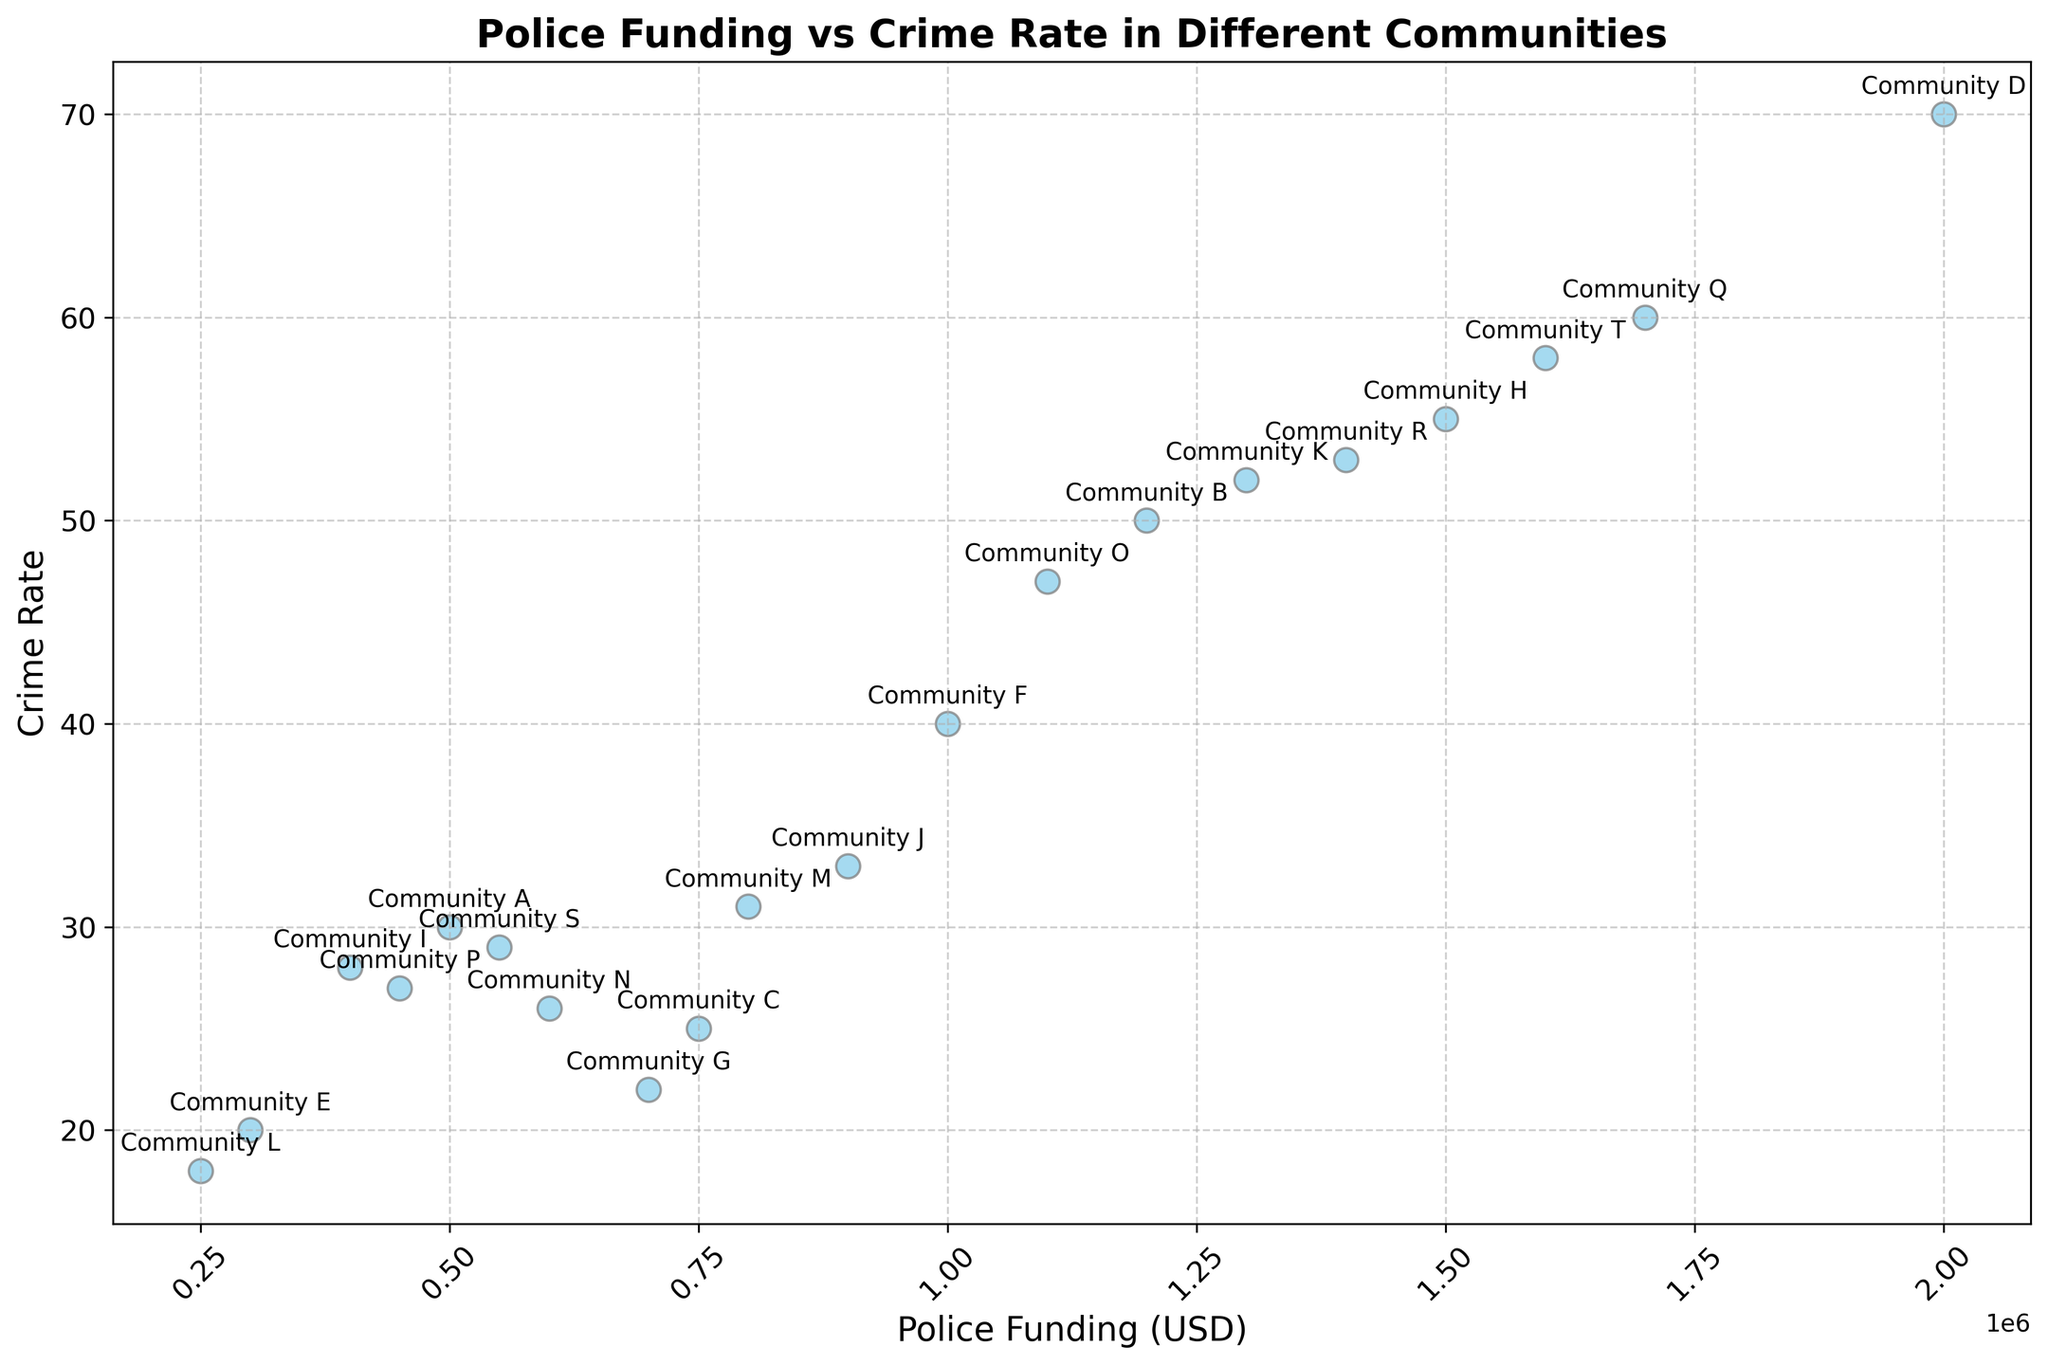what is the range of police funding among the communities? The range is calculated by subtracting the minimum police funding value from the maximum police funding value. The minimum value is $250,000, and the maximum value is $2,000,000. Therefore, the range is $2,000,000 - $250,000 = $1,750,000
Answer: $1,750,000 Which community has the highest crime rate, and what is its police funding? By inspecting the figure, the community with the highest crime rate is Community D, with a crime rate of 70. Its corresponding police funding is $2,000,000
Answer: Community D, $2,000,000 Are there any communities with similar crime rates but significantly different police funding? Communities B and K both have crime rates around 50, but Community B has a police funding of $1,200,000, while Community K has $1,300,000. These values are similar and not significantly different. We can look at Communities G and I both have crime rates around 22-28, but their police funding is $700,000 and $400,000 respectively.
Answer: Communities G and I What is the average crime rate in communities with police funding over $1,000,000? There are six communities with police funding over $1,000,000 (B, D, H, K, O, Q, R, T). Their respective crime rates are 50, 70, 55, 52, 47, 60, 53, and 58. Summing these gives 445. Dividing by 8, we get an average crime rate of 445 / 8 = 55.625.
Answer: 55.625 Is there a community with lower police funding but higher crime rate than another community with higher police funding and lower crime rate? Community E has police funding of $300,000 and a crime rate of 20. Community N has police funding of $600,000 but a lower crime rate of 26. This does not meet the criteria. Looking further, Community S has police funding of $550,000 and a crime rate of 29, while Community J has police funding of $900,000 and a crime rate of 33. So, in this figure, Community A ($500,000 funding, 30 crime rate) and Community K ($1,300,000 funding, 52 crime rate) would be a match for this query.
Answer: Community A, Community K What is the median police funding value among the communities? To find the median, first list out the police funding values in ascending order: $250,000, $300,000, $400,000, $450,000, $500,000, $550,000, $600,000, $700,000, $750,000, $800,000, $900,000, $1,000,000, $1,100,000, $1,200,000, $1,300,000, $1,400,000, $1,500,000, $1,600,000, $1,700,000, $2,000,000. The median is the middle value in this list, so with 20 values, it is the average of the 10th and 11th values: ($800,000 + $900,000) / 2 = $850,000
Answer: $850,000 